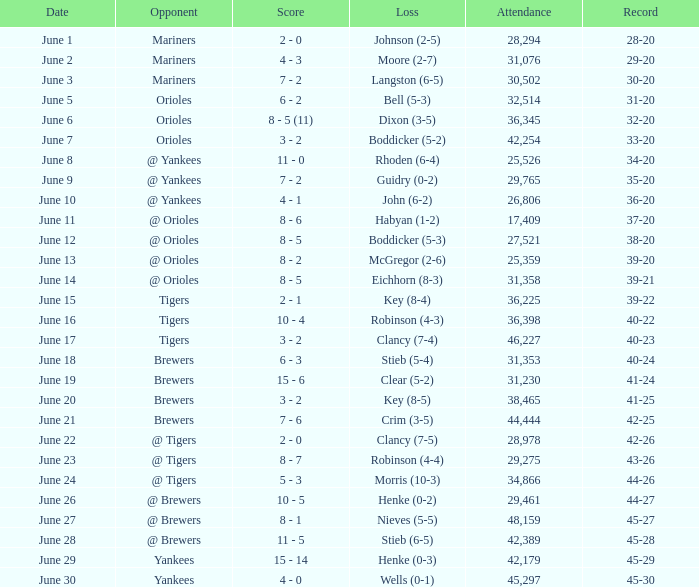Parse the full table. {'header': ['Date', 'Opponent', 'Score', 'Loss', 'Attendance', 'Record'], 'rows': [['June 1', 'Mariners', '2 - 0', 'Johnson (2-5)', '28,294', '28-20'], ['June 2', 'Mariners', '4 - 3', 'Moore (2-7)', '31,076', '29-20'], ['June 3', 'Mariners', '7 - 2', 'Langston (6-5)', '30,502', '30-20'], ['June 5', 'Orioles', '6 - 2', 'Bell (5-3)', '32,514', '31-20'], ['June 6', 'Orioles', '8 - 5 (11)', 'Dixon (3-5)', '36,345', '32-20'], ['June 7', 'Orioles', '3 - 2', 'Boddicker (5-2)', '42,254', '33-20'], ['June 8', '@ Yankees', '11 - 0', 'Rhoden (6-4)', '25,526', '34-20'], ['June 9', '@ Yankees', '7 - 2', 'Guidry (0-2)', '29,765', '35-20'], ['June 10', '@ Yankees', '4 - 1', 'John (6-2)', '26,806', '36-20'], ['June 11', '@ Orioles', '8 - 6', 'Habyan (1-2)', '17,409', '37-20'], ['June 12', '@ Orioles', '8 - 5', 'Boddicker (5-3)', '27,521', '38-20'], ['June 13', '@ Orioles', '8 - 2', 'McGregor (2-6)', '25,359', '39-20'], ['June 14', '@ Orioles', '8 - 5', 'Eichhorn (8-3)', '31,358', '39-21'], ['June 15', 'Tigers', '2 - 1', 'Key (8-4)', '36,225', '39-22'], ['June 16', 'Tigers', '10 - 4', 'Robinson (4-3)', '36,398', '40-22'], ['June 17', 'Tigers', '3 - 2', 'Clancy (7-4)', '46,227', '40-23'], ['June 18', 'Brewers', '6 - 3', 'Stieb (5-4)', '31,353', '40-24'], ['June 19', 'Brewers', '15 - 6', 'Clear (5-2)', '31,230', '41-24'], ['June 20', 'Brewers', '3 - 2', 'Key (8-5)', '38,465', '41-25'], ['June 21', 'Brewers', '7 - 6', 'Crim (3-5)', '44,444', '42-25'], ['June 22', '@ Tigers', '2 - 0', 'Clancy (7-5)', '28,978', '42-26'], ['June 23', '@ Tigers', '8 - 7', 'Robinson (4-4)', '29,275', '43-26'], ['June 24', '@ Tigers', '5 - 3', 'Morris (10-3)', '34,866', '44-26'], ['June 26', '@ Brewers', '10 - 5', 'Henke (0-2)', '29,461', '44-27'], ['June 27', '@ Brewers', '8 - 1', 'Nieves (5-5)', '48,159', '45-27'], ['June 28', '@ Brewers', '11 - 5', 'Stieb (6-5)', '42,389', '45-28'], ['June 29', 'Yankees', '15 - 14', 'Henke (0-3)', '42,179', '45-29'], ['June 30', 'Yankees', '4 - 0', 'Wells (0-1)', '45,297', '45-30']]} What was the score when the Blue Jays had a record of 39-20? 8 - 2. 